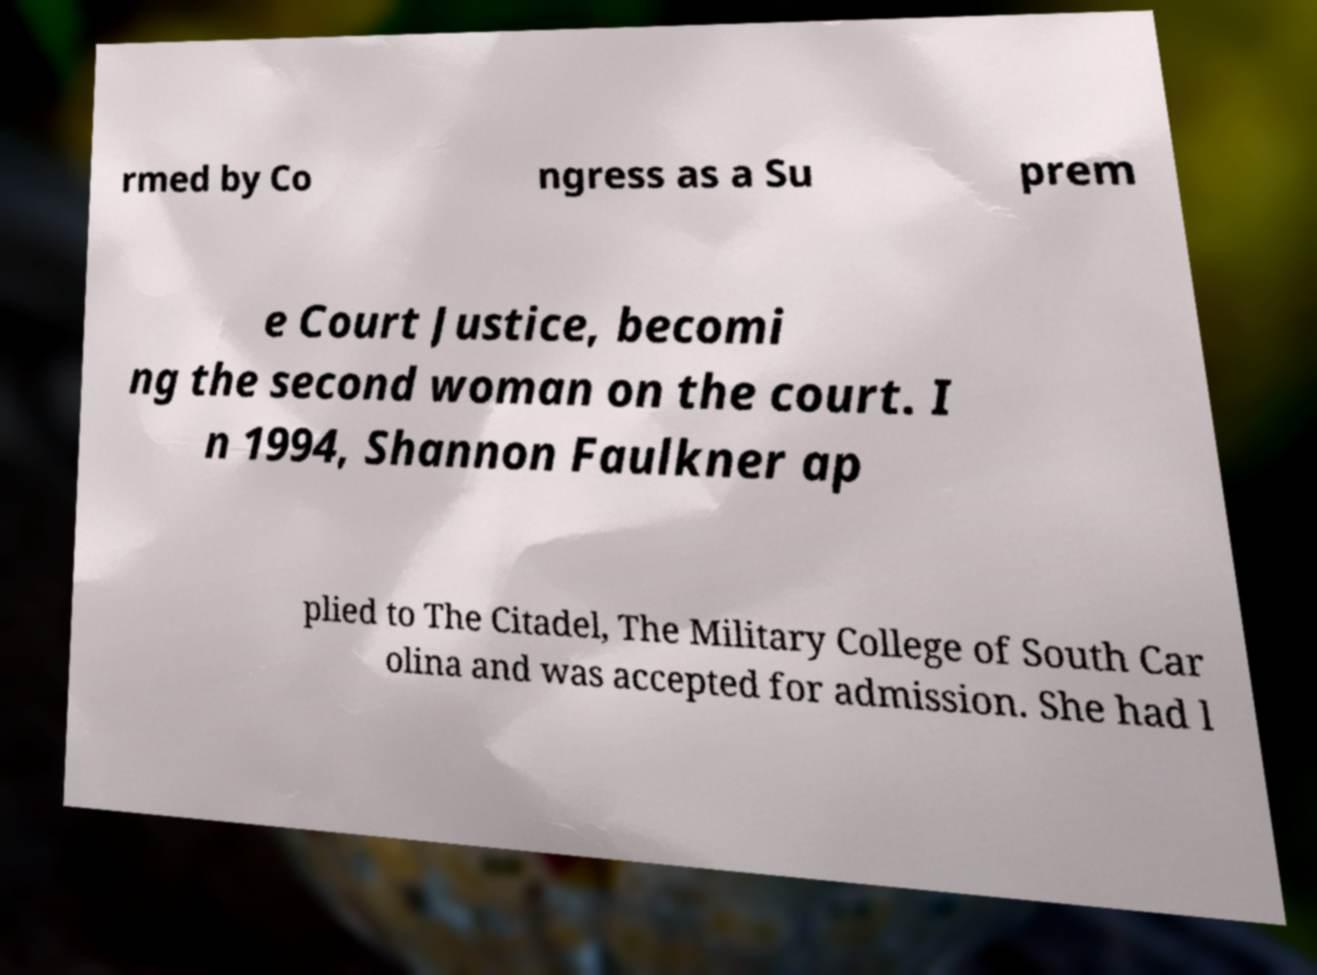Could you extract and type out the text from this image? rmed by Co ngress as a Su prem e Court Justice, becomi ng the second woman on the court. I n 1994, Shannon Faulkner ap plied to The Citadel, The Military College of South Car olina and was accepted for admission. She had l 